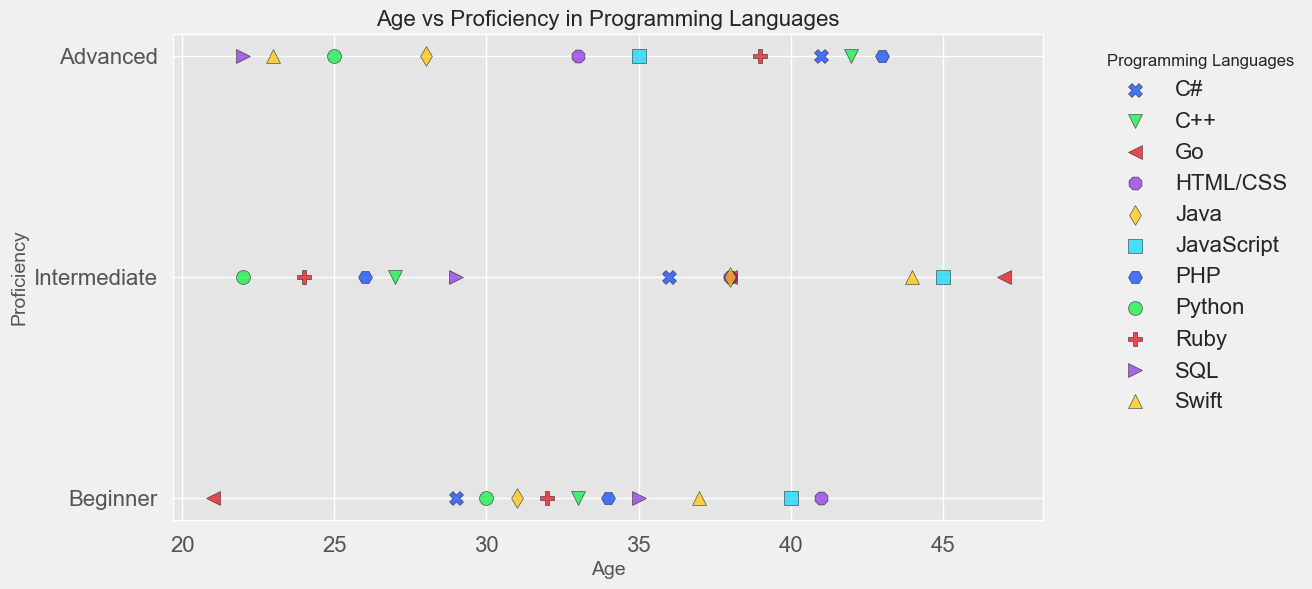What is the proficiency level mostly seen in job seekers aged 35? By inspecting the data for age 35, we can identify the proficiency levels of the corresponding job seekers in the figure. By looking closer, we can see job seekers with age 35 have two proficiency levels: advanced (JavaScript) and beginner (SQL).
Answer: Advanced and Beginner Which programming language has the most job seekers classified as 'Advanced'? Examine the green marks in the scatter plot to identify which programming language has the most green marks. Python has one, JavaScript has one, Java has one, Ruby has one, C# has one, PHP has one, Swift has one, SQL has one, and HTML/CSS has one. Hence, each of these languages has an equal number of job seekers at the 'Advanced' level.
Answer: All listed languages have 1 'Advanced' How many job seekers with 'Intermediate' proficiency in C++ are there? To answer, look at blue markers representing C++ proficiency levels on the scatter plot. By counting, you will find there is just one marker for C++ shown at 'Intermediate'.
Answer: 1 What is the average age of job seekers with 'Beginner' proficiency in Java? Observe the data points for Java and identify those marked in red (Beginner). The ages associated are 31. Therefore, the average is simply the only age present for beginner proficiency level in Java.
Answer: 31 Which programming languages have beginners only above the age of 30? Evaluate all red markers across the entire plot for job seekers above the age of 30 and note the corresponding programming languages. You will see Java (age 31), Ruby (age 32), C++ (age 33), Swift (age 37), PHP (age 34), HTML/CSS (age 41), and Go (age 38).
Answer: Java, Ruby, C++, Swift, PHP, HTML/CSS, Go 